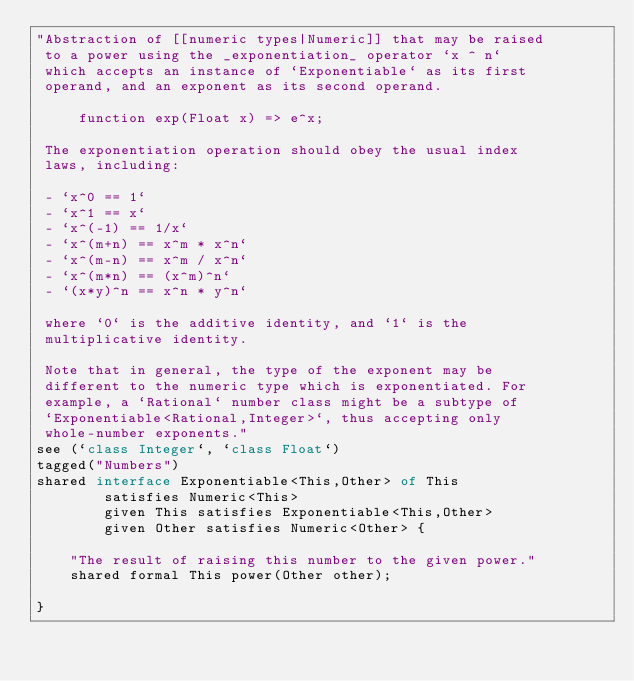<code> <loc_0><loc_0><loc_500><loc_500><_Ceylon_>"Abstraction of [[numeric types|Numeric]] that may be raised 
 to a power using the _exponentiation_ operator `x ^ n` 
 which accepts an instance of `Exponentiable` as its first
 operand, and an exponent as its second operand.
 
     function exp(Float x) => e^x;
 
 The exponentiation operation should obey the usual index
 laws, including:
 
 - `x^0 == 1`
 - `x^1 == x`
 - `x^(-1) == 1/x`
 - `x^(m+n) == x^m * x^n`
 - `x^(m-n) == x^m / x^n`
 - `x^(m*n) == (x^m)^n`
 - `(x*y)^n == x^n * y^n`
 
 where `0` is the additive identity, and `1` is the 
 multiplicative identity.
 
 Note that in general, the type of the exponent may be 
 different to the numeric type which is exponentiated. For
 example, a `Rational` number class might be a subtype of
 `Exponentiable<Rational,Integer>`, thus accepting only
 whole-number exponents."
see (`class Integer`, `class Float`)
tagged("Numbers")
shared interface Exponentiable<This,Other> of This
        satisfies Numeric<This>
        given This satisfies Exponentiable<This,Other> 
        given Other satisfies Numeric<Other> {

    "The result of raising this number to the given power."
    shared formal This power(Other other);
    
} </code> 